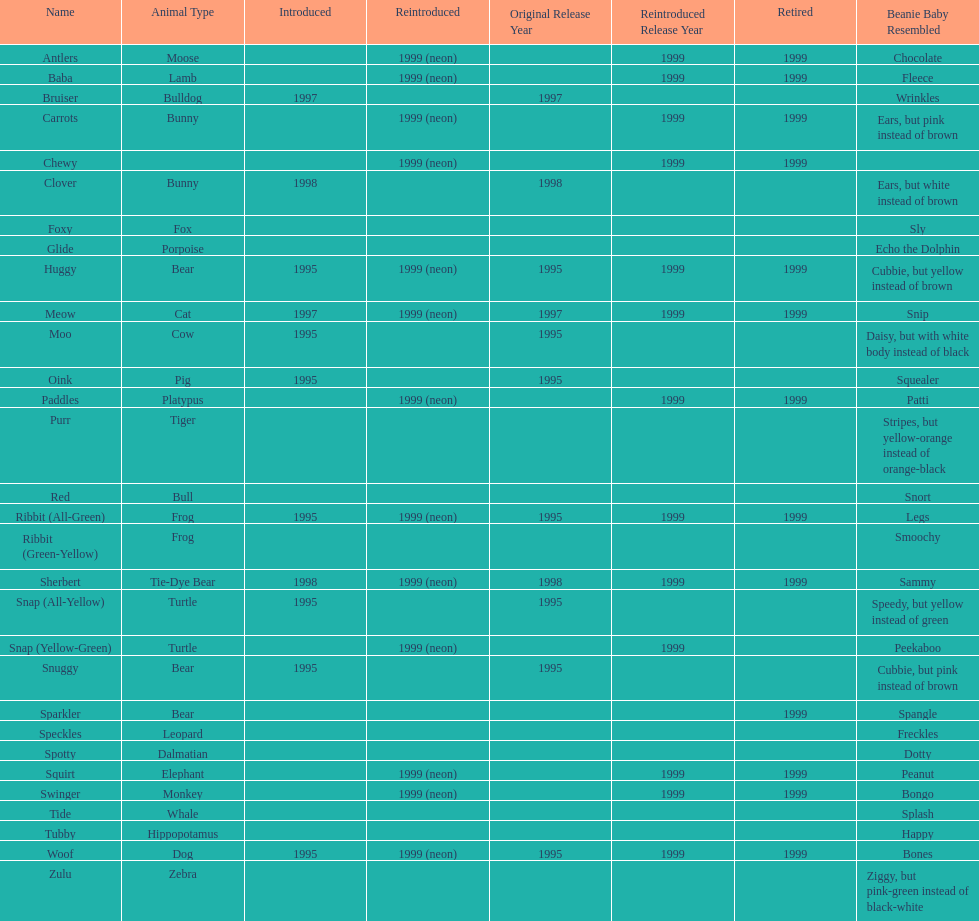What is the name of the pillow pal listed after clover? Foxy. 